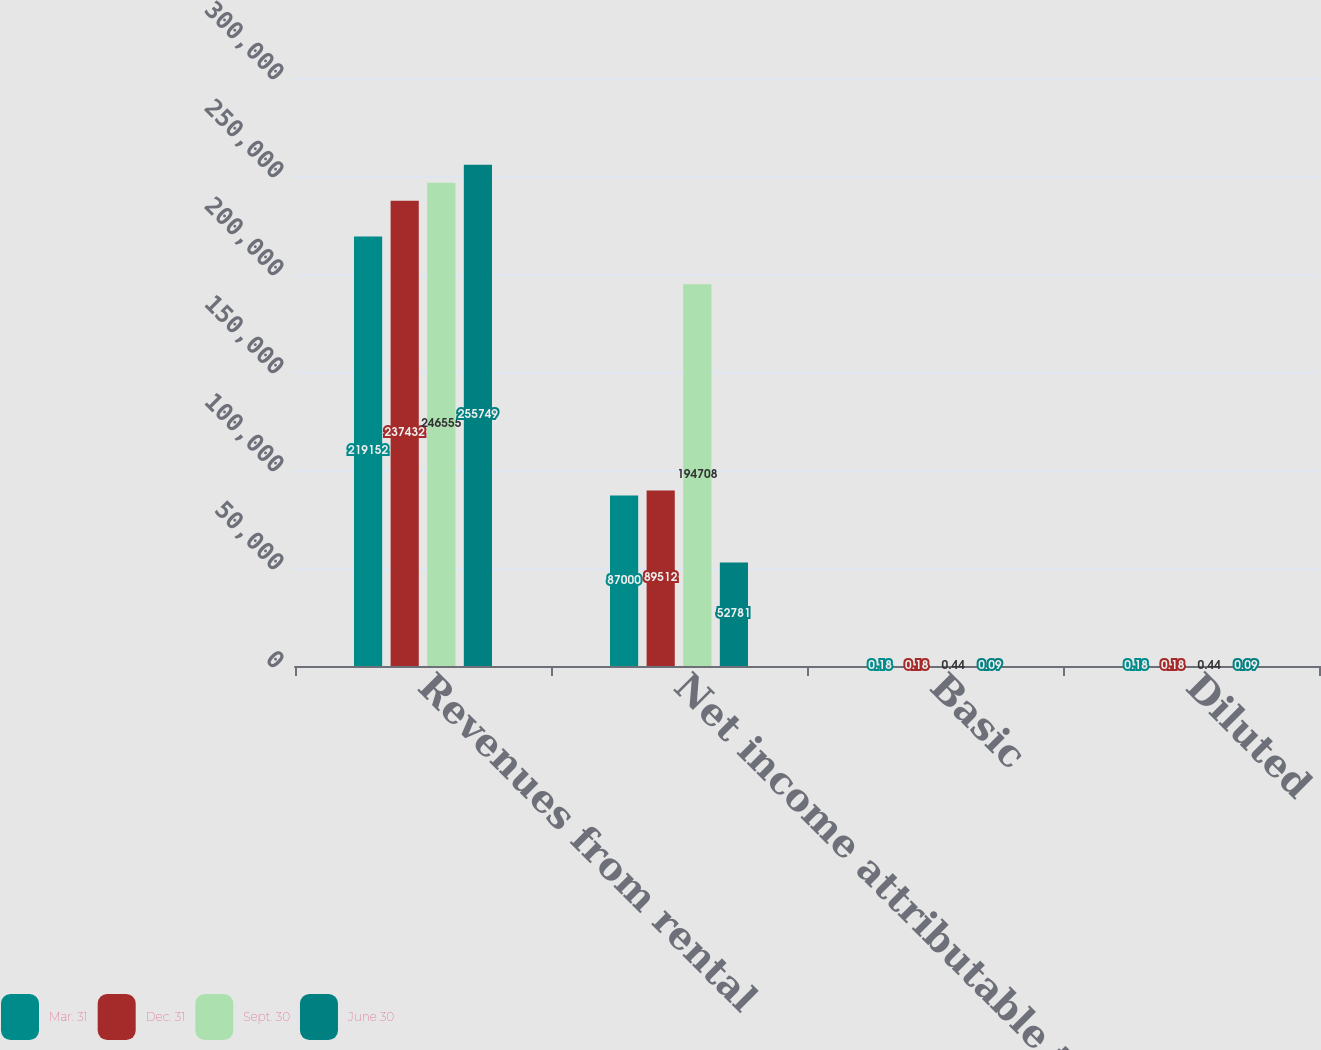Convert chart to OTSL. <chart><loc_0><loc_0><loc_500><loc_500><stacked_bar_chart><ecel><fcel>Revenues from rental<fcel>Net income attributable to the<fcel>Basic<fcel>Diluted<nl><fcel>Mar. 31<fcel>219152<fcel>87000<fcel>0.18<fcel>0.18<nl><fcel>Dec. 31<fcel>237432<fcel>89512<fcel>0.18<fcel>0.18<nl><fcel>Sept. 30<fcel>246555<fcel>194708<fcel>0.44<fcel>0.44<nl><fcel>June 30<fcel>255749<fcel>52781<fcel>0.09<fcel>0.09<nl></chart> 